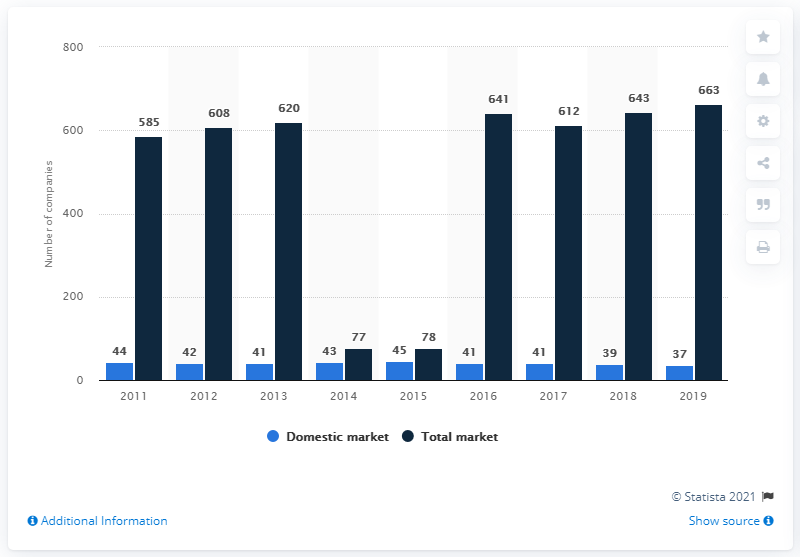Draw attention to some important aspects in this diagram. In 2015, the Portuguese domestic insurance market had 45 companies. At the end of 2019, the total number of companies in Portugal was 663. As of December 2019, there were 37 insurance companies operating in Portugal. 